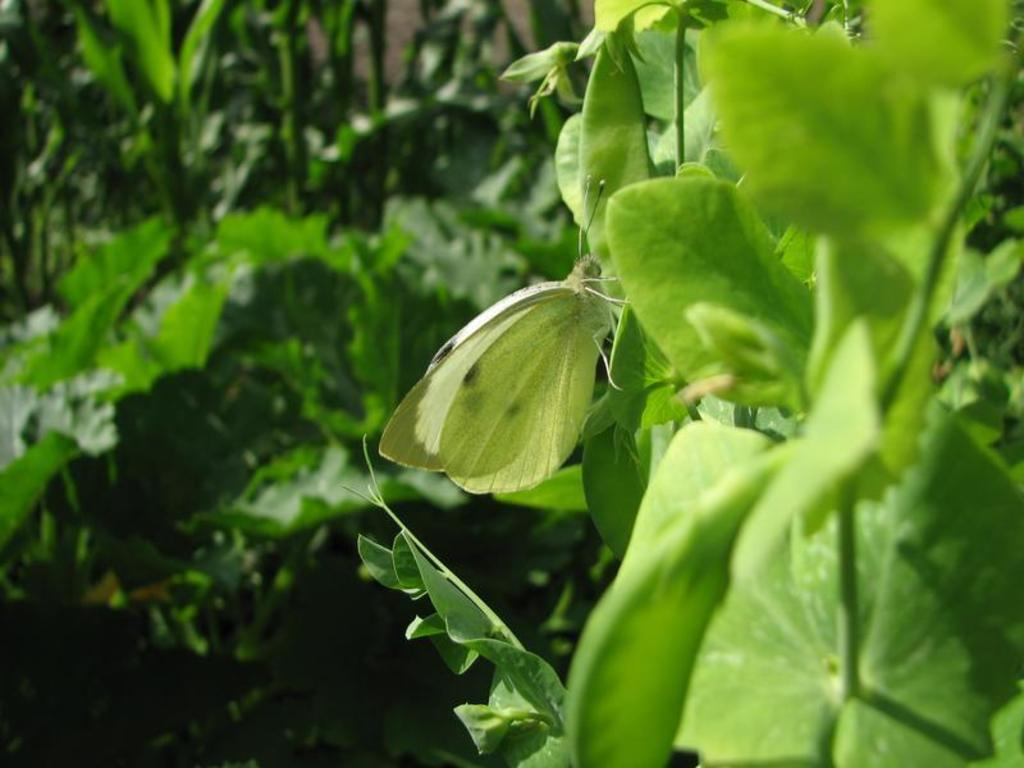What type of vegetation can be seen in the image? There are trees and plants in the image. Can you describe the insect in the image? There is an insect on a leaf in the image. What is the writer doing in the image? There is no writer present in the image; it features trees, plants, and an insect on a leaf. 